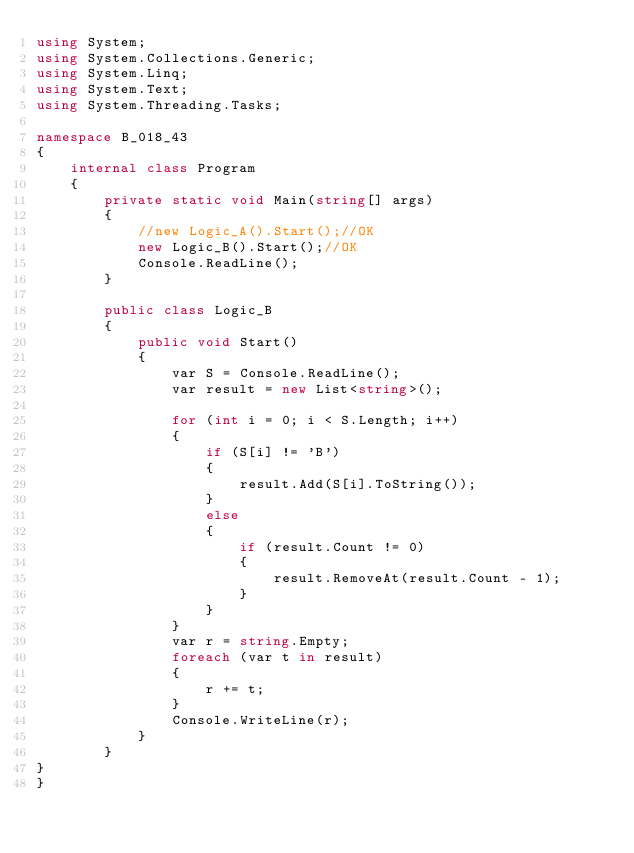<code> <loc_0><loc_0><loc_500><loc_500><_C#_>using System;
using System.Collections.Generic;
using System.Linq;
using System.Text;
using System.Threading.Tasks;

namespace B_018_43
{
    internal class Program
    {
        private static void Main(string[] args)
        {
            //new Logic_A().Start();//OK
            new Logic_B().Start();//OK
            Console.ReadLine();
        }

        public class Logic_B
        {
            public void Start()
            {
                var S = Console.ReadLine();
                var result = new List<string>();

                for (int i = 0; i < S.Length; i++)
                {
                    if (S[i] != 'B')
                    {
                        result.Add(S[i].ToString());
                    }
                    else
                    {
                        if (result.Count != 0)
                        {
                            result.RemoveAt(result.Count - 1);
                        }
                    }
                }
                var r = string.Empty;
                foreach (var t in result)
                {
                    r += t;
                }
                Console.WriteLine(r);
            }
        }
}
}</code> 